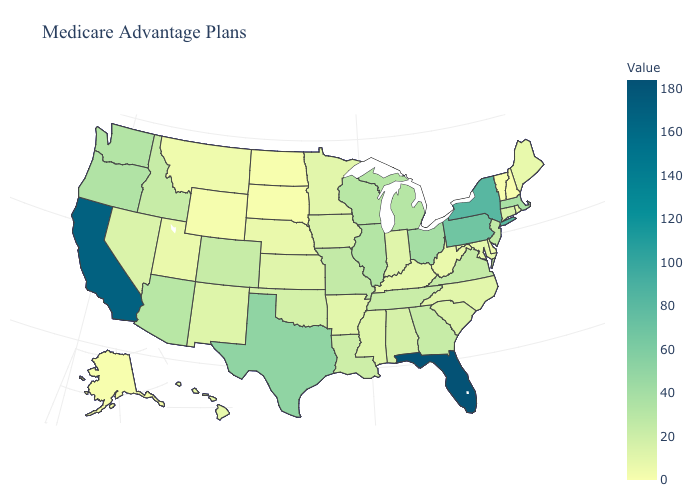Which states have the lowest value in the South?
Give a very brief answer. Delaware. Among the states that border Montana , which have the highest value?
Concise answer only. Idaho. Which states have the lowest value in the MidWest?
Keep it brief. North Dakota, South Dakota. Which states have the highest value in the USA?
Give a very brief answer. Florida. 